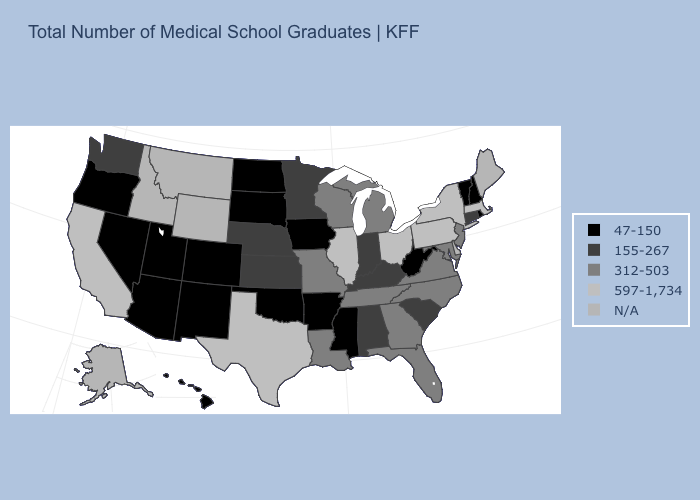Name the states that have a value in the range 47-150?
Quick response, please. Arizona, Arkansas, Colorado, Hawaii, Iowa, Mississippi, Nevada, New Hampshire, New Mexico, North Dakota, Oklahoma, Oregon, Rhode Island, South Dakota, Utah, Vermont, West Virginia. Which states have the lowest value in the USA?
Keep it brief. Arizona, Arkansas, Colorado, Hawaii, Iowa, Mississippi, Nevada, New Hampshire, New Mexico, North Dakota, Oklahoma, Oregon, Rhode Island, South Dakota, Utah, Vermont, West Virginia. What is the value of Washington?
Be succinct. 155-267. Does Connecticut have the highest value in the USA?
Quick response, please. No. What is the lowest value in the USA?
Concise answer only. 47-150. Among the states that border South Carolina , which have the highest value?
Give a very brief answer. Georgia, North Carolina. Name the states that have a value in the range N/A?
Be succinct. Alaska, Delaware, Idaho, Maine, Montana, Wyoming. Name the states that have a value in the range 597-1,734?
Concise answer only. California, Illinois, Massachusetts, New York, Ohio, Pennsylvania, Texas. Name the states that have a value in the range 597-1,734?
Write a very short answer. California, Illinois, Massachusetts, New York, Ohio, Pennsylvania, Texas. What is the value of Pennsylvania?
Give a very brief answer. 597-1,734. What is the value of Virginia?
Quick response, please. 312-503. Among the states that border Indiana , does Michigan have the highest value?
Write a very short answer. No. Which states have the lowest value in the South?
Short answer required. Arkansas, Mississippi, Oklahoma, West Virginia. What is the value of Mississippi?
Write a very short answer. 47-150. What is the value of Montana?
Be succinct. N/A. 